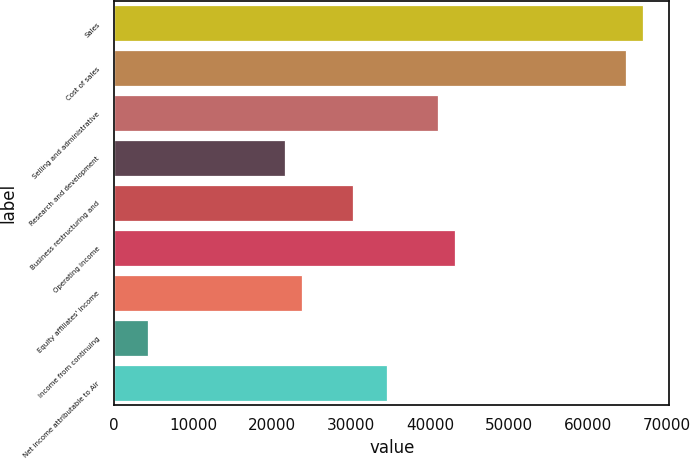Convert chart. <chart><loc_0><loc_0><loc_500><loc_500><bar_chart><fcel>Sales<fcel>Cost of sales<fcel>Selling and administrative<fcel>Research and development<fcel>Business restructuring and<fcel>Operating income<fcel>Equity affiliates' income<fcel>Income from continuing<fcel>Net income attributable to Air<nl><fcel>66954.1<fcel>64794.4<fcel>41037.4<fcel>21600<fcel>30238.8<fcel>43197.2<fcel>23759.7<fcel>4322.21<fcel>34558.3<nl></chart> 